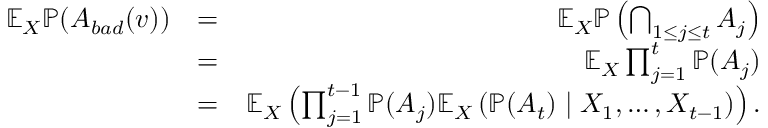Convert formula to latex. <formula><loc_0><loc_0><loc_500><loc_500>\begin{array} { r l r } { \mathbb { E } _ { X } \mathbb { P } ( A _ { b a d } ( v ) ) } & { = } & { \mathbb { E } _ { X } \mathbb { P } \left ( \bigcap _ { 1 \leq j \leq t } A _ { j } \right ) } \\ & { = } & { \mathbb { E } _ { X } \prod _ { j = 1 } ^ { t } \mathbb { P } ( A _ { j } ) } \\ & { = } & { \mathbb { E } _ { X } \left ( \prod _ { j = 1 } ^ { t - 1 } \mathbb { P } ( A _ { j } ) \mathbb { E } _ { X } \left ( \mathbb { P } ( A _ { t } ) | X _ { 1 } , \dots , X _ { t - 1 } \right ) \right ) . } \end{array}</formula> 